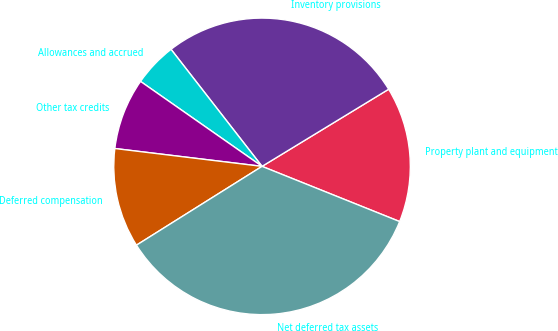Convert chart. <chart><loc_0><loc_0><loc_500><loc_500><pie_chart><fcel>Property plant and equipment<fcel>Inventory provisions<fcel>Allowances and accrued<fcel>Other tax credits<fcel>Deferred compensation<fcel>Net deferred tax assets<nl><fcel>14.78%<fcel>26.81%<fcel>4.77%<fcel>7.79%<fcel>10.84%<fcel>35.01%<nl></chart> 